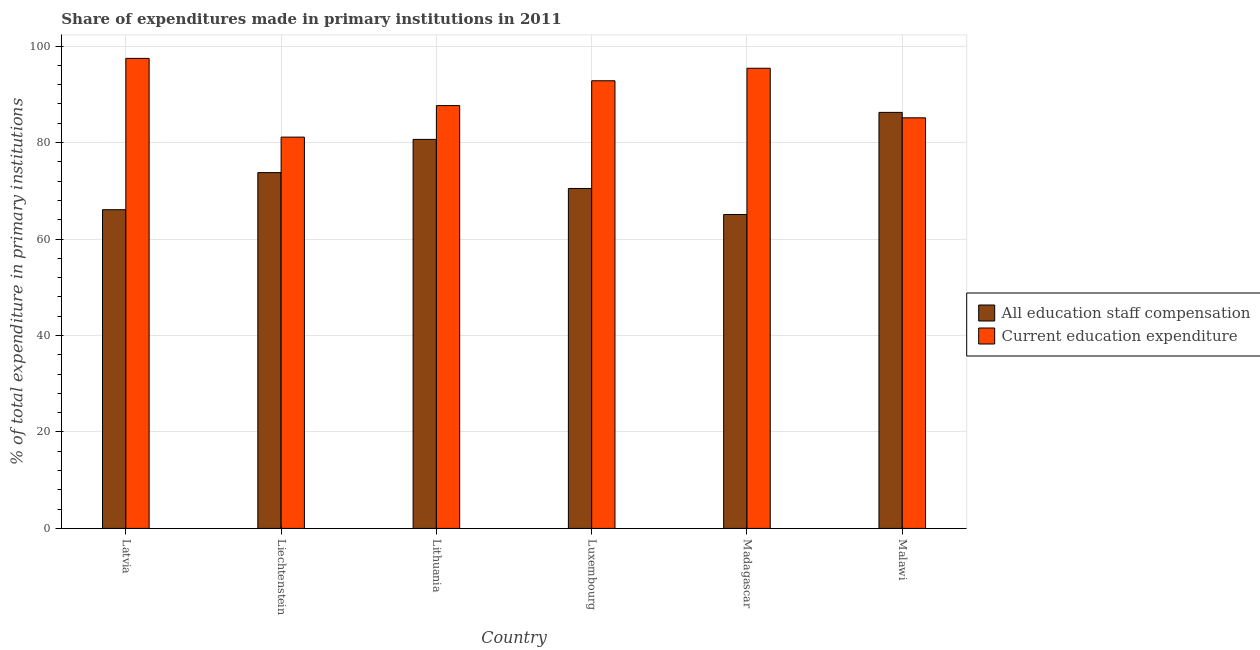Are the number of bars per tick equal to the number of legend labels?
Provide a succinct answer. Yes. How many bars are there on the 4th tick from the left?
Offer a terse response. 2. What is the label of the 3rd group of bars from the left?
Provide a succinct answer. Lithuania. In how many cases, is the number of bars for a given country not equal to the number of legend labels?
Make the answer very short. 0. What is the expenditure in staff compensation in Liechtenstein?
Give a very brief answer. 73.76. Across all countries, what is the maximum expenditure in staff compensation?
Provide a short and direct response. 86.25. Across all countries, what is the minimum expenditure in staff compensation?
Offer a terse response. 65.07. In which country was the expenditure in staff compensation maximum?
Your answer should be very brief. Malawi. In which country was the expenditure in education minimum?
Make the answer very short. Liechtenstein. What is the total expenditure in staff compensation in the graph?
Your response must be concise. 442.3. What is the difference between the expenditure in staff compensation in Liechtenstein and that in Malawi?
Offer a terse response. -12.49. What is the difference between the expenditure in staff compensation in Madagascar and the expenditure in education in Lithuania?
Offer a very short reply. -22.59. What is the average expenditure in staff compensation per country?
Give a very brief answer. 73.72. What is the difference between the expenditure in staff compensation and expenditure in education in Liechtenstein?
Your answer should be compact. -7.36. In how many countries, is the expenditure in education greater than 64 %?
Offer a very short reply. 6. What is the ratio of the expenditure in education in Madagascar to that in Malawi?
Give a very brief answer. 1.12. What is the difference between the highest and the second highest expenditure in staff compensation?
Give a very brief answer. 5.6. What is the difference between the highest and the lowest expenditure in staff compensation?
Keep it short and to the point. 21.18. What does the 2nd bar from the left in Latvia represents?
Your answer should be compact. Current education expenditure. What does the 2nd bar from the right in Latvia represents?
Give a very brief answer. All education staff compensation. How many bars are there?
Provide a succinct answer. 12. Are the values on the major ticks of Y-axis written in scientific E-notation?
Provide a short and direct response. No. Does the graph contain grids?
Give a very brief answer. Yes. Where does the legend appear in the graph?
Your response must be concise. Center right. What is the title of the graph?
Your response must be concise. Share of expenditures made in primary institutions in 2011. Does "Taxes on exports" appear as one of the legend labels in the graph?
Ensure brevity in your answer.  No. What is the label or title of the Y-axis?
Offer a very short reply. % of total expenditure in primary institutions. What is the % of total expenditure in primary institutions in All education staff compensation in Latvia?
Keep it short and to the point. 66.07. What is the % of total expenditure in primary institutions of Current education expenditure in Latvia?
Make the answer very short. 97.45. What is the % of total expenditure in primary institutions of All education staff compensation in Liechtenstein?
Keep it short and to the point. 73.76. What is the % of total expenditure in primary institutions in Current education expenditure in Liechtenstein?
Your answer should be very brief. 81.13. What is the % of total expenditure in primary institutions of All education staff compensation in Lithuania?
Your response must be concise. 80.66. What is the % of total expenditure in primary institutions of Current education expenditure in Lithuania?
Your answer should be compact. 87.66. What is the % of total expenditure in primary institutions in All education staff compensation in Luxembourg?
Offer a terse response. 70.48. What is the % of total expenditure in primary institutions of Current education expenditure in Luxembourg?
Give a very brief answer. 92.81. What is the % of total expenditure in primary institutions in All education staff compensation in Madagascar?
Provide a short and direct response. 65.07. What is the % of total expenditure in primary institutions of Current education expenditure in Madagascar?
Keep it short and to the point. 95.4. What is the % of total expenditure in primary institutions in All education staff compensation in Malawi?
Give a very brief answer. 86.25. What is the % of total expenditure in primary institutions in Current education expenditure in Malawi?
Provide a succinct answer. 85.13. Across all countries, what is the maximum % of total expenditure in primary institutions of All education staff compensation?
Give a very brief answer. 86.25. Across all countries, what is the maximum % of total expenditure in primary institutions in Current education expenditure?
Your response must be concise. 97.45. Across all countries, what is the minimum % of total expenditure in primary institutions in All education staff compensation?
Make the answer very short. 65.07. Across all countries, what is the minimum % of total expenditure in primary institutions in Current education expenditure?
Give a very brief answer. 81.13. What is the total % of total expenditure in primary institutions in All education staff compensation in the graph?
Offer a terse response. 442.3. What is the total % of total expenditure in primary institutions of Current education expenditure in the graph?
Keep it short and to the point. 539.57. What is the difference between the % of total expenditure in primary institutions of All education staff compensation in Latvia and that in Liechtenstein?
Your response must be concise. -7.69. What is the difference between the % of total expenditure in primary institutions in Current education expenditure in Latvia and that in Liechtenstein?
Offer a very short reply. 16.32. What is the difference between the % of total expenditure in primary institutions in All education staff compensation in Latvia and that in Lithuania?
Your response must be concise. -14.58. What is the difference between the % of total expenditure in primary institutions in Current education expenditure in Latvia and that in Lithuania?
Your answer should be very brief. 9.79. What is the difference between the % of total expenditure in primary institutions of All education staff compensation in Latvia and that in Luxembourg?
Give a very brief answer. -4.41. What is the difference between the % of total expenditure in primary institutions in Current education expenditure in Latvia and that in Luxembourg?
Ensure brevity in your answer.  4.64. What is the difference between the % of total expenditure in primary institutions of Current education expenditure in Latvia and that in Madagascar?
Make the answer very short. 2.05. What is the difference between the % of total expenditure in primary institutions of All education staff compensation in Latvia and that in Malawi?
Ensure brevity in your answer.  -20.18. What is the difference between the % of total expenditure in primary institutions of Current education expenditure in Latvia and that in Malawi?
Make the answer very short. 12.32. What is the difference between the % of total expenditure in primary institutions in All education staff compensation in Liechtenstein and that in Lithuania?
Keep it short and to the point. -6.89. What is the difference between the % of total expenditure in primary institutions in Current education expenditure in Liechtenstein and that in Lithuania?
Give a very brief answer. -6.53. What is the difference between the % of total expenditure in primary institutions of All education staff compensation in Liechtenstein and that in Luxembourg?
Your answer should be compact. 3.28. What is the difference between the % of total expenditure in primary institutions of Current education expenditure in Liechtenstein and that in Luxembourg?
Your response must be concise. -11.68. What is the difference between the % of total expenditure in primary institutions in All education staff compensation in Liechtenstein and that in Madagascar?
Make the answer very short. 8.69. What is the difference between the % of total expenditure in primary institutions in Current education expenditure in Liechtenstein and that in Madagascar?
Your answer should be very brief. -14.28. What is the difference between the % of total expenditure in primary institutions of All education staff compensation in Liechtenstein and that in Malawi?
Your response must be concise. -12.49. What is the difference between the % of total expenditure in primary institutions of Current education expenditure in Liechtenstein and that in Malawi?
Your response must be concise. -4. What is the difference between the % of total expenditure in primary institutions of All education staff compensation in Lithuania and that in Luxembourg?
Your response must be concise. 10.17. What is the difference between the % of total expenditure in primary institutions of Current education expenditure in Lithuania and that in Luxembourg?
Give a very brief answer. -5.15. What is the difference between the % of total expenditure in primary institutions of All education staff compensation in Lithuania and that in Madagascar?
Your answer should be very brief. 15.58. What is the difference between the % of total expenditure in primary institutions of Current education expenditure in Lithuania and that in Madagascar?
Offer a very short reply. -7.74. What is the difference between the % of total expenditure in primary institutions in All education staff compensation in Lithuania and that in Malawi?
Your answer should be compact. -5.6. What is the difference between the % of total expenditure in primary institutions of Current education expenditure in Lithuania and that in Malawi?
Give a very brief answer. 2.53. What is the difference between the % of total expenditure in primary institutions in All education staff compensation in Luxembourg and that in Madagascar?
Your response must be concise. 5.41. What is the difference between the % of total expenditure in primary institutions in Current education expenditure in Luxembourg and that in Madagascar?
Ensure brevity in your answer.  -2.59. What is the difference between the % of total expenditure in primary institutions of All education staff compensation in Luxembourg and that in Malawi?
Your response must be concise. -15.77. What is the difference between the % of total expenditure in primary institutions of Current education expenditure in Luxembourg and that in Malawi?
Your answer should be very brief. 7.68. What is the difference between the % of total expenditure in primary institutions of All education staff compensation in Madagascar and that in Malawi?
Your response must be concise. -21.18. What is the difference between the % of total expenditure in primary institutions in Current education expenditure in Madagascar and that in Malawi?
Provide a short and direct response. 10.27. What is the difference between the % of total expenditure in primary institutions of All education staff compensation in Latvia and the % of total expenditure in primary institutions of Current education expenditure in Liechtenstein?
Offer a terse response. -15.05. What is the difference between the % of total expenditure in primary institutions in All education staff compensation in Latvia and the % of total expenditure in primary institutions in Current education expenditure in Lithuania?
Give a very brief answer. -21.59. What is the difference between the % of total expenditure in primary institutions in All education staff compensation in Latvia and the % of total expenditure in primary institutions in Current education expenditure in Luxembourg?
Ensure brevity in your answer.  -26.74. What is the difference between the % of total expenditure in primary institutions of All education staff compensation in Latvia and the % of total expenditure in primary institutions of Current education expenditure in Madagascar?
Your answer should be very brief. -29.33. What is the difference between the % of total expenditure in primary institutions in All education staff compensation in Latvia and the % of total expenditure in primary institutions in Current education expenditure in Malawi?
Keep it short and to the point. -19.05. What is the difference between the % of total expenditure in primary institutions of All education staff compensation in Liechtenstein and the % of total expenditure in primary institutions of Current education expenditure in Lithuania?
Give a very brief answer. -13.9. What is the difference between the % of total expenditure in primary institutions in All education staff compensation in Liechtenstein and the % of total expenditure in primary institutions in Current education expenditure in Luxembourg?
Offer a terse response. -19.05. What is the difference between the % of total expenditure in primary institutions of All education staff compensation in Liechtenstein and the % of total expenditure in primary institutions of Current education expenditure in Madagascar?
Offer a very short reply. -21.64. What is the difference between the % of total expenditure in primary institutions in All education staff compensation in Liechtenstein and the % of total expenditure in primary institutions in Current education expenditure in Malawi?
Keep it short and to the point. -11.36. What is the difference between the % of total expenditure in primary institutions of All education staff compensation in Lithuania and the % of total expenditure in primary institutions of Current education expenditure in Luxembourg?
Offer a terse response. -12.15. What is the difference between the % of total expenditure in primary institutions in All education staff compensation in Lithuania and the % of total expenditure in primary institutions in Current education expenditure in Madagascar?
Make the answer very short. -14.75. What is the difference between the % of total expenditure in primary institutions in All education staff compensation in Lithuania and the % of total expenditure in primary institutions in Current education expenditure in Malawi?
Your response must be concise. -4.47. What is the difference between the % of total expenditure in primary institutions in All education staff compensation in Luxembourg and the % of total expenditure in primary institutions in Current education expenditure in Madagascar?
Provide a short and direct response. -24.92. What is the difference between the % of total expenditure in primary institutions of All education staff compensation in Luxembourg and the % of total expenditure in primary institutions of Current education expenditure in Malawi?
Your answer should be compact. -14.65. What is the difference between the % of total expenditure in primary institutions of All education staff compensation in Madagascar and the % of total expenditure in primary institutions of Current education expenditure in Malawi?
Your answer should be very brief. -20.05. What is the average % of total expenditure in primary institutions of All education staff compensation per country?
Ensure brevity in your answer.  73.72. What is the average % of total expenditure in primary institutions in Current education expenditure per country?
Keep it short and to the point. 89.93. What is the difference between the % of total expenditure in primary institutions in All education staff compensation and % of total expenditure in primary institutions in Current education expenditure in Latvia?
Provide a succinct answer. -31.38. What is the difference between the % of total expenditure in primary institutions in All education staff compensation and % of total expenditure in primary institutions in Current education expenditure in Liechtenstein?
Your response must be concise. -7.36. What is the difference between the % of total expenditure in primary institutions in All education staff compensation and % of total expenditure in primary institutions in Current education expenditure in Lithuania?
Your response must be concise. -7. What is the difference between the % of total expenditure in primary institutions in All education staff compensation and % of total expenditure in primary institutions in Current education expenditure in Luxembourg?
Your answer should be compact. -22.33. What is the difference between the % of total expenditure in primary institutions of All education staff compensation and % of total expenditure in primary institutions of Current education expenditure in Madagascar?
Provide a succinct answer. -30.33. What is the difference between the % of total expenditure in primary institutions of All education staff compensation and % of total expenditure in primary institutions of Current education expenditure in Malawi?
Your answer should be very brief. 1.13. What is the ratio of the % of total expenditure in primary institutions in All education staff compensation in Latvia to that in Liechtenstein?
Offer a very short reply. 0.9. What is the ratio of the % of total expenditure in primary institutions in Current education expenditure in Latvia to that in Liechtenstein?
Your answer should be compact. 1.2. What is the ratio of the % of total expenditure in primary institutions of All education staff compensation in Latvia to that in Lithuania?
Your answer should be very brief. 0.82. What is the ratio of the % of total expenditure in primary institutions in Current education expenditure in Latvia to that in Lithuania?
Offer a terse response. 1.11. What is the ratio of the % of total expenditure in primary institutions in All education staff compensation in Latvia to that in Madagascar?
Make the answer very short. 1.02. What is the ratio of the % of total expenditure in primary institutions of Current education expenditure in Latvia to that in Madagascar?
Provide a succinct answer. 1.02. What is the ratio of the % of total expenditure in primary institutions in All education staff compensation in Latvia to that in Malawi?
Make the answer very short. 0.77. What is the ratio of the % of total expenditure in primary institutions in Current education expenditure in Latvia to that in Malawi?
Offer a terse response. 1.14. What is the ratio of the % of total expenditure in primary institutions of All education staff compensation in Liechtenstein to that in Lithuania?
Your answer should be compact. 0.91. What is the ratio of the % of total expenditure in primary institutions of Current education expenditure in Liechtenstein to that in Lithuania?
Provide a succinct answer. 0.93. What is the ratio of the % of total expenditure in primary institutions in All education staff compensation in Liechtenstein to that in Luxembourg?
Keep it short and to the point. 1.05. What is the ratio of the % of total expenditure in primary institutions in Current education expenditure in Liechtenstein to that in Luxembourg?
Offer a very short reply. 0.87. What is the ratio of the % of total expenditure in primary institutions of All education staff compensation in Liechtenstein to that in Madagascar?
Keep it short and to the point. 1.13. What is the ratio of the % of total expenditure in primary institutions in Current education expenditure in Liechtenstein to that in Madagascar?
Give a very brief answer. 0.85. What is the ratio of the % of total expenditure in primary institutions in All education staff compensation in Liechtenstein to that in Malawi?
Your answer should be very brief. 0.86. What is the ratio of the % of total expenditure in primary institutions in Current education expenditure in Liechtenstein to that in Malawi?
Provide a short and direct response. 0.95. What is the ratio of the % of total expenditure in primary institutions of All education staff compensation in Lithuania to that in Luxembourg?
Your response must be concise. 1.14. What is the ratio of the % of total expenditure in primary institutions in Current education expenditure in Lithuania to that in Luxembourg?
Your response must be concise. 0.94. What is the ratio of the % of total expenditure in primary institutions in All education staff compensation in Lithuania to that in Madagascar?
Keep it short and to the point. 1.24. What is the ratio of the % of total expenditure in primary institutions of Current education expenditure in Lithuania to that in Madagascar?
Provide a short and direct response. 0.92. What is the ratio of the % of total expenditure in primary institutions in All education staff compensation in Lithuania to that in Malawi?
Offer a terse response. 0.94. What is the ratio of the % of total expenditure in primary institutions in Current education expenditure in Lithuania to that in Malawi?
Ensure brevity in your answer.  1.03. What is the ratio of the % of total expenditure in primary institutions in All education staff compensation in Luxembourg to that in Madagascar?
Ensure brevity in your answer.  1.08. What is the ratio of the % of total expenditure in primary institutions of Current education expenditure in Luxembourg to that in Madagascar?
Provide a succinct answer. 0.97. What is the ratio of the % of total expenditure in primary institutions of All education staff compensation in Luxembourg to that in Malawi?
Offer a terse response. 0.82. What is the ratio of the % of total expenditure in primary institutions of Current education expenditure in Luxembourg to that in Malawi?
Make the answer very short. 1.09. What is the ratio of the % of total expenditure in primary institutions in All education staff compensation in Madagascar to that in Malawi?
Your response must be concise. 0.75. What is the ratio of the % of total expenditure in primary institutions of Current education expenditure in Madagascar to that in Malawi?
Keep it short and to the point. 1.12. What is the difference between the highest and the second highest % of total expenditure in primary institutions of All education staff compensation?
Keep it short and to the point. 5.6. What is the difference between the highest and the second highest % of total expenditure in primary institutions in Current education expenditure?
Keep it short and to the point. 2.05. What is the difference between the highest and the lowest % of total expenditure in primary institutions in All education staff compensation?
Offer a very short reply. 21.18. What is the difference between the highest and the lowest % of total expenditure in primary institutions of Current education expenditure?
Make the answer very short. 16.32. 